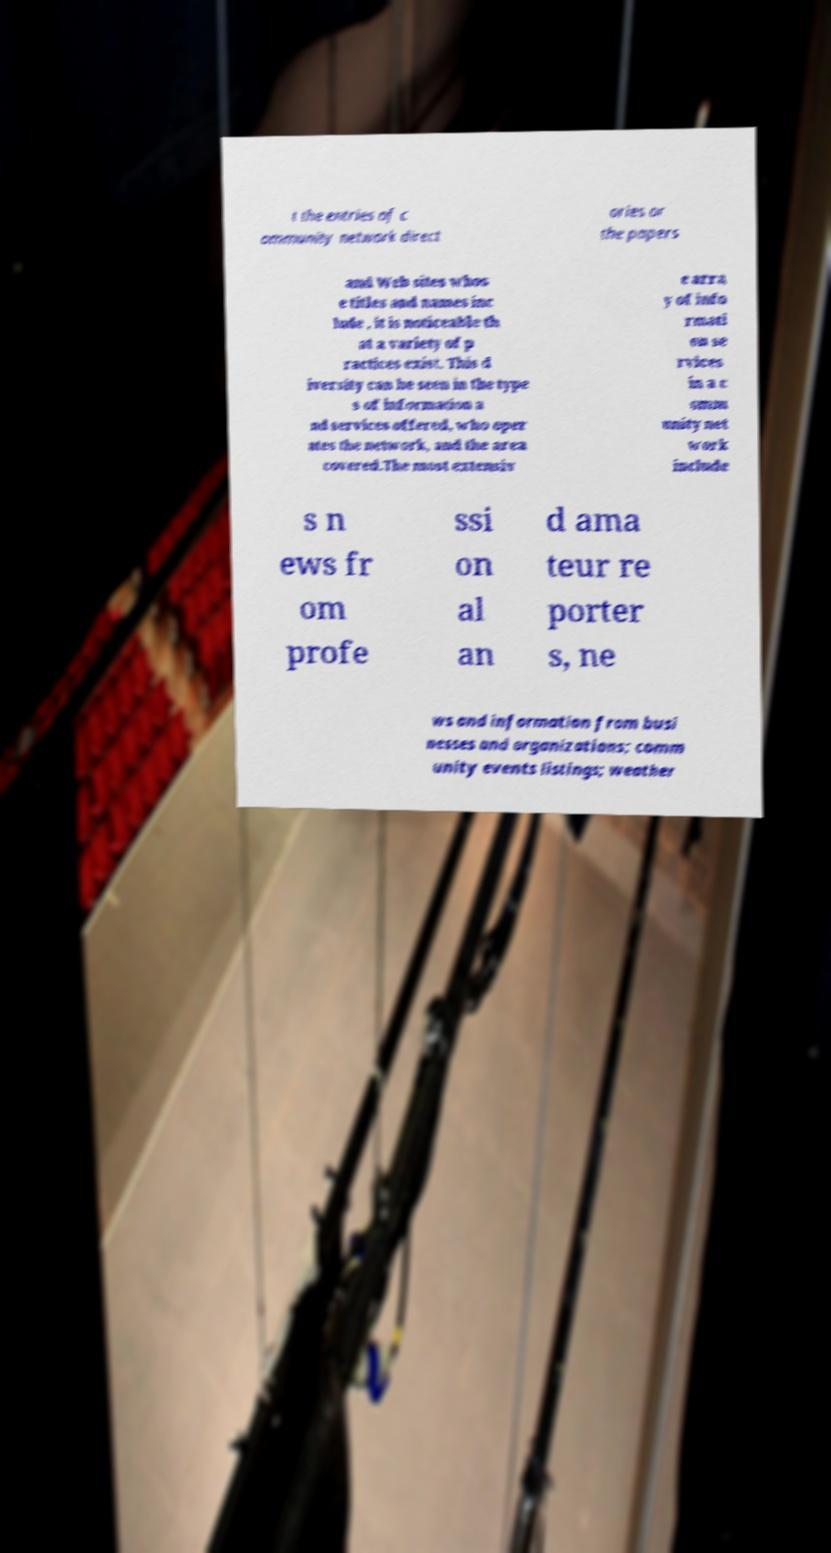Please identify and transcribe the text found in this image. t the entries of c ommunity network direct ories or the papers and Web sites whos e titles and names inc lude , it is noticeable th at a variety of p ractices exist. This d iversity can be seen in the type s of information a nd services offered, who oper ates the network, and the area covered.The most extensiv e arra y of info rmati on se rvices in a c omm unity net work include s n ews fr om profe ssi on al an d ama teur re porter s, ne ws and information from busi nesses and organizations; comm unity events listings; weather 